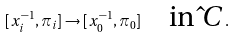Convert formula to latex. <formula><loc_0><loc_0><loc_500><loc_500>[ x _ { i } ^ { - 1 } , \pi _ { i } ] \to [ x _ { 0 } ^ { - 1 } , \pi _ { 0 } ] \quad \text {in $\hat{ }C$} .</formula> 